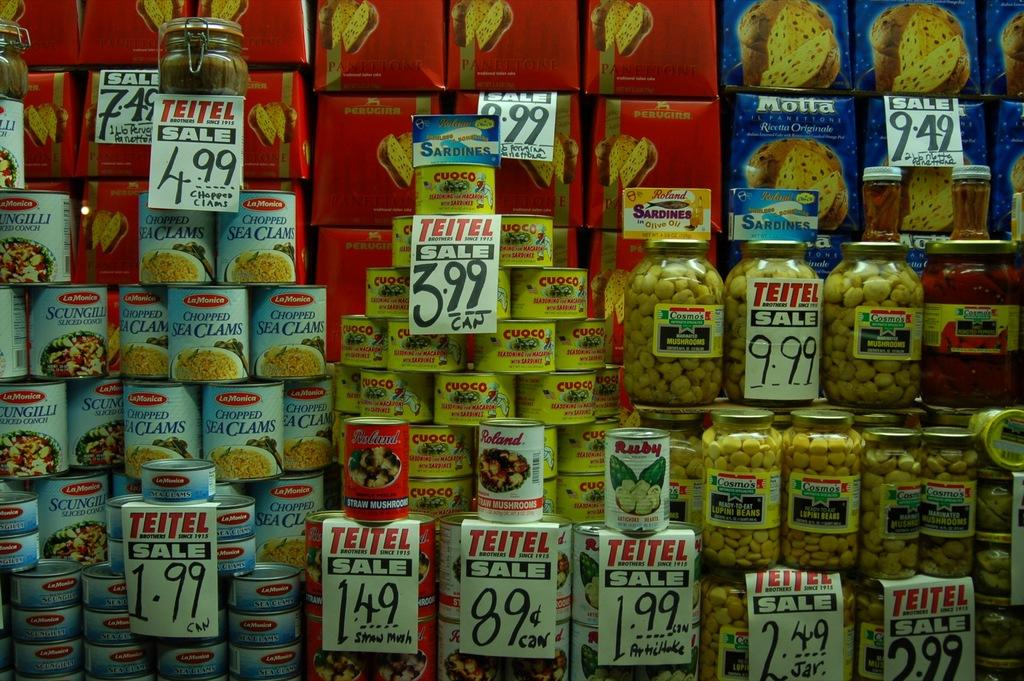<image>
Relay a brief, clear account of the picture shown. Items for sale with a tag that says Teitel Sale. 